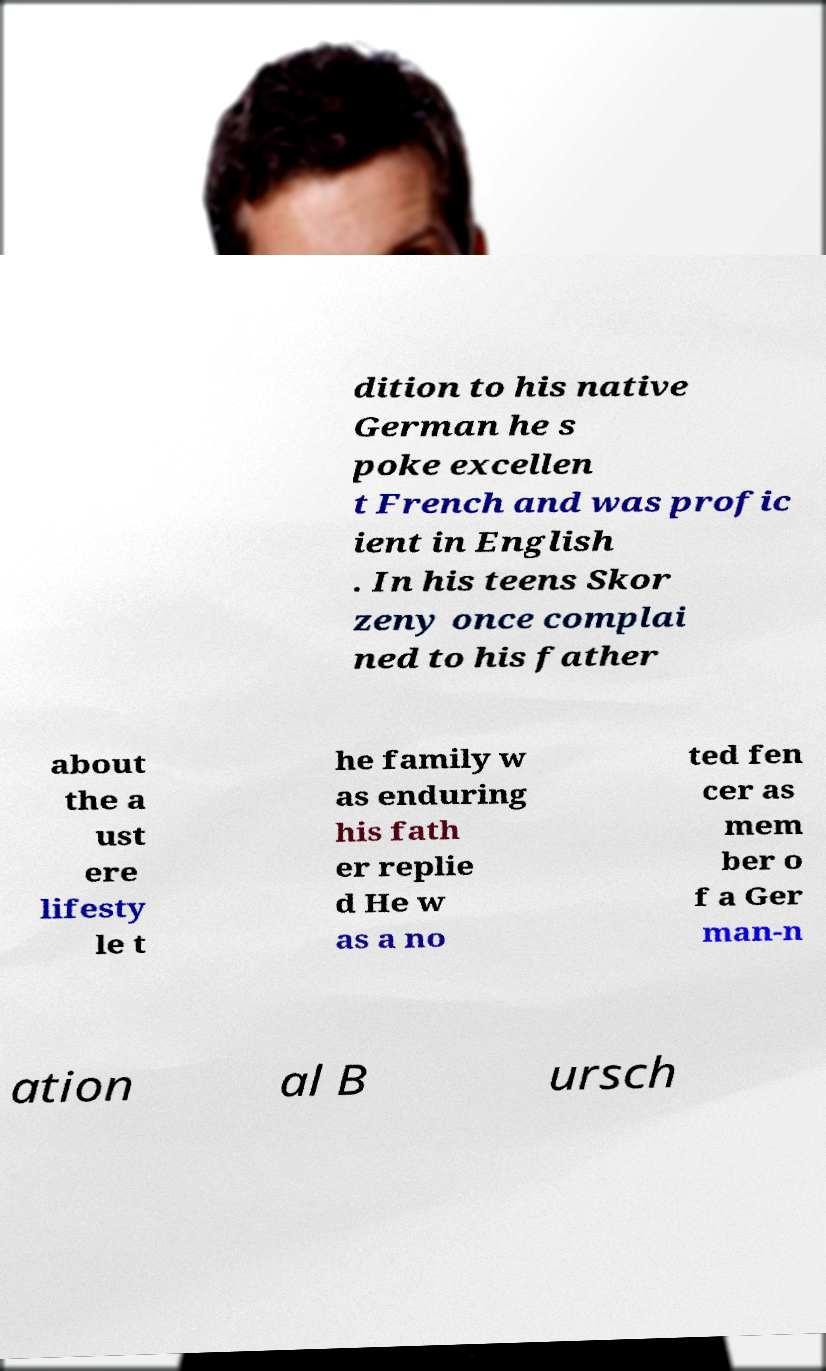Please read and relay the text visible in this image. What does it say? dition to his native German he s poke excellen t French and was profic ient in English . In his teens Skor zeny once complai ned to his father about the a ust ere lifesty le t he family w as enduring his fath er replie d He w as a no ted fen cer as mem ber o f a Ger man-n ation al B ursch 